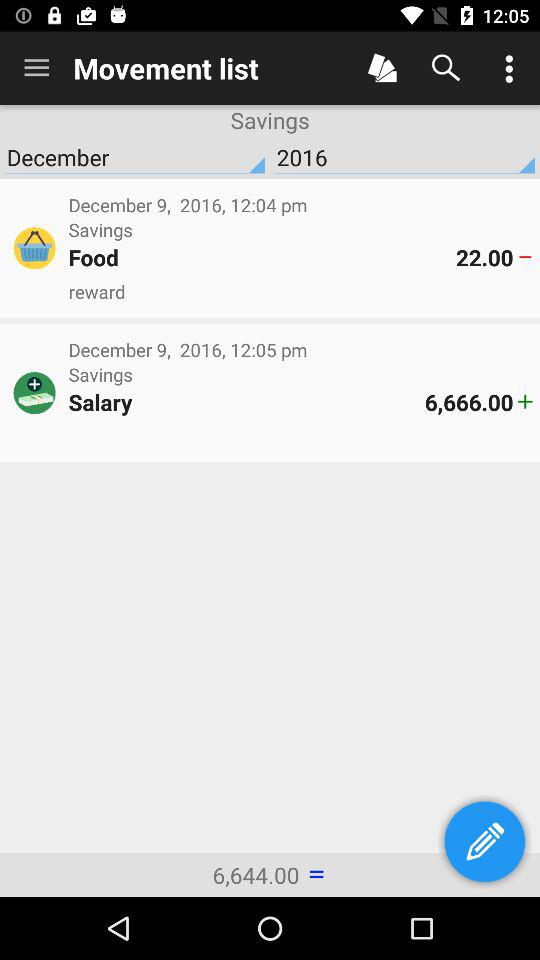What date is shown? The shown date is December 9, 2016. 